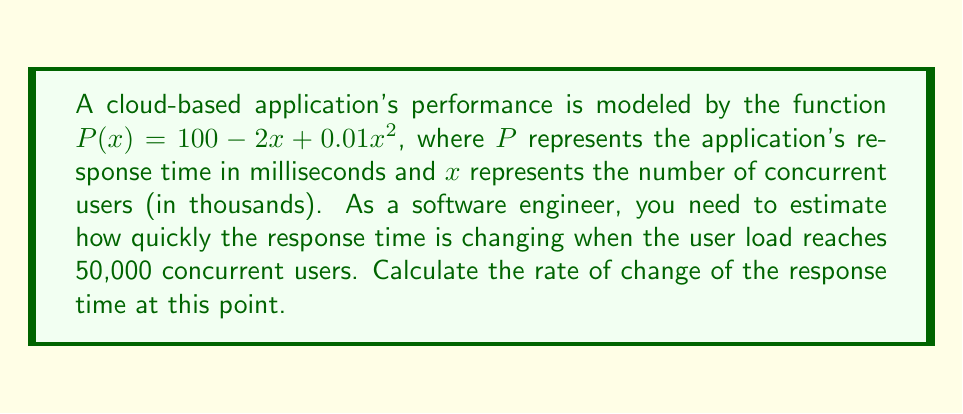Could you help me with this problem? To solve this problem, we need to use the concept of derivatives. The derivative of a function at a point gives us the rate of change at that point.

Step 1: Find the derivative of the function $P(x)$.
$$P(x) = 100 - 2x + 0.01x^2$$
$$P'(x) = -2 + 0.02x$$

Step 2: We need to evaluate the derivative at $x = 50$ (since 50,000 users = 50 thousand users).
$$P'(50) = -2 + 0.02(50)$$
$$P'(50) = -2 + 1$$
$$P'(50) = -1$$

Step 3: Interpret the result.
The negative value indicates that the response time is decreasing at this point. Specifically, it's decreasing at a rate of 1 millisecond per thousand users.

To express this in terms of individual users:
$$-1 \text{ ms/1000 users} = -0.001 \text{ ms/user}$$

This means that at 50,000 users, for each additional user, the response time is decreasing by 0.001 milliseconds.
Answer: -0.001 ms/user 